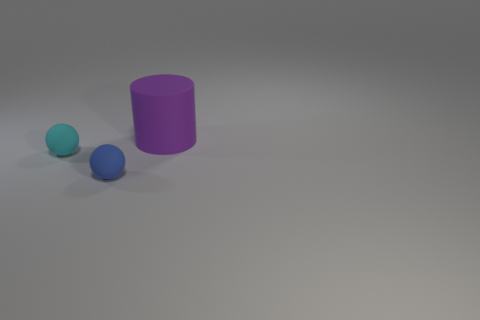Add 1 small gray matte objects. How many objects exist? 4 Subtract all balls. How many objects are left? 1 Subtract all matte balls. Subtract all cylinders. How many objects are left? 0 Add 3 large cylinders. How many large cylinders are left? 4 Add 1 large rubber objects. How many large rubber objects exist? 2 Subtract 0 yellow cylinders. How many objects are left? 3 